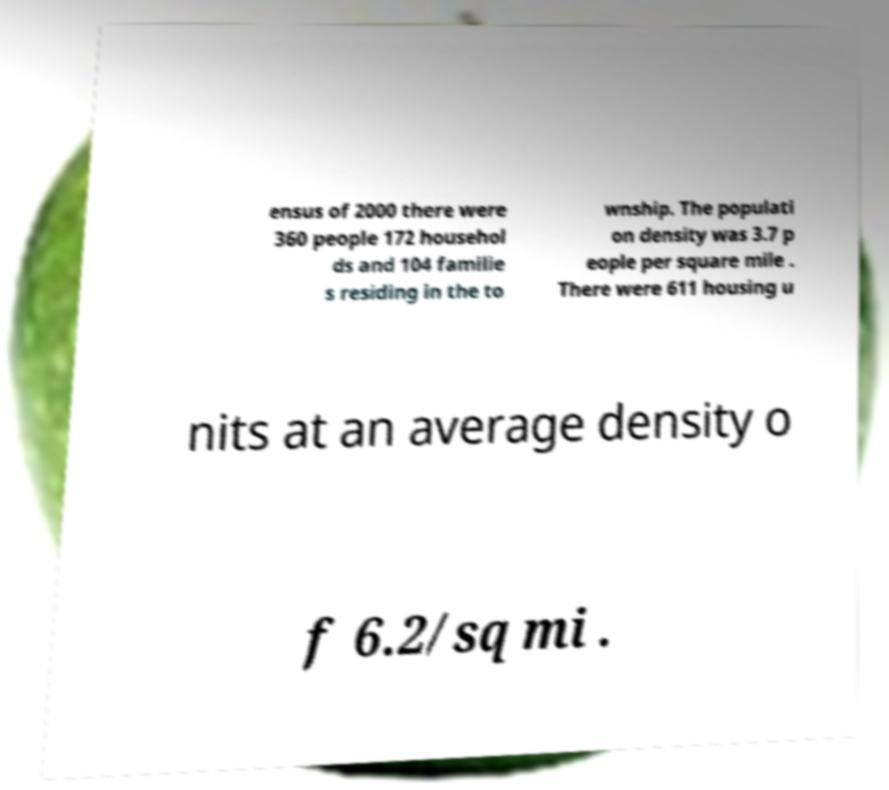Can you read and provide the text displayed in the image?This photo seems to have some interesting text. Can you extract and type it out for me? ensus of 2000 there were 360 people 172 househol ds and 104 familie s residing in the to wnship. The populati on density was 3.7 p eople per square mile . There were 611 housing u nits at an average density o f 6.2/sq mi . 